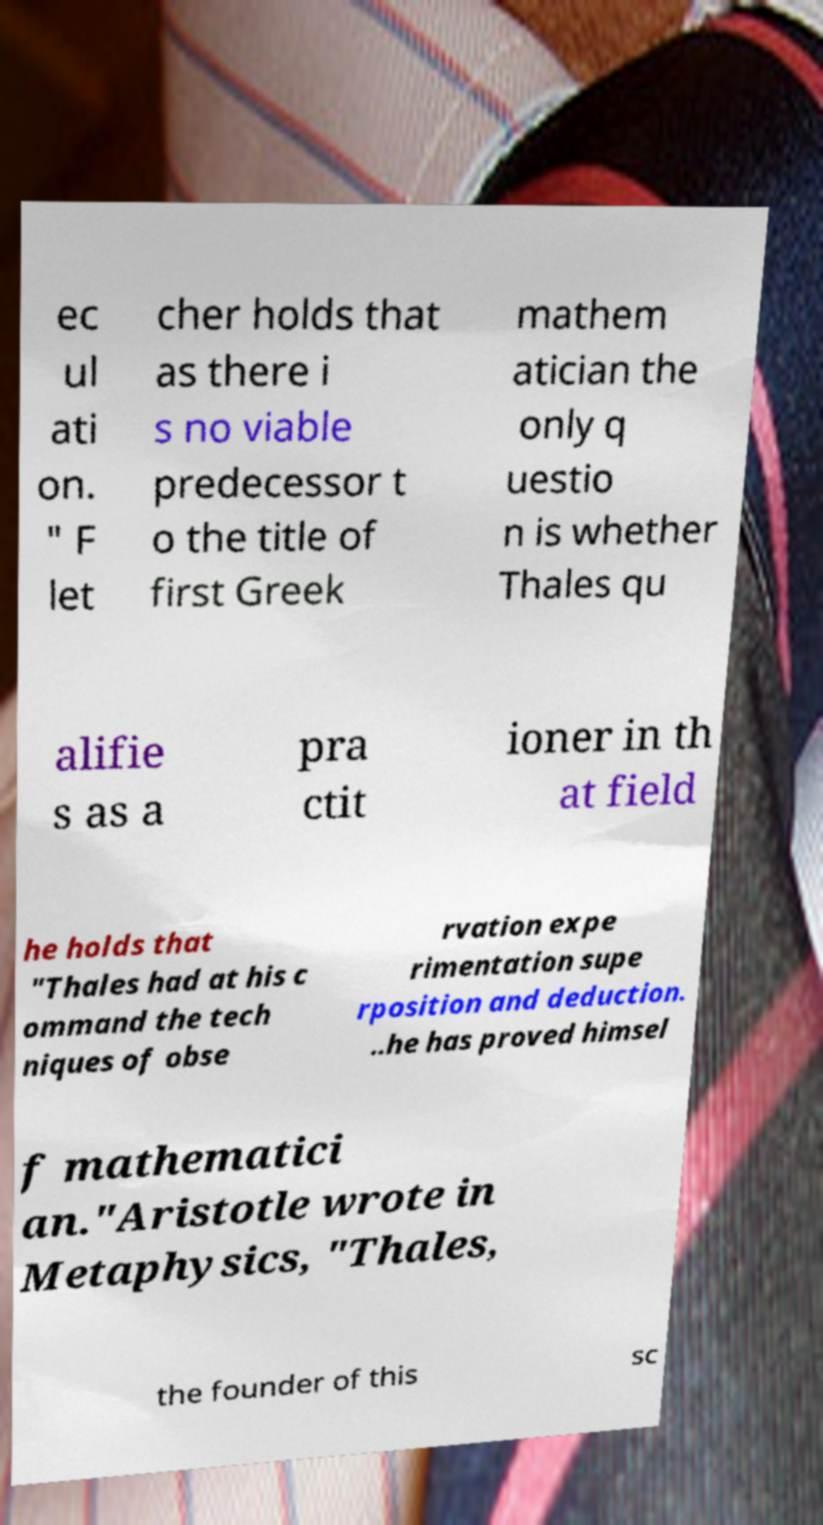What messages or text are displayed in this image? I need them in a readable, typed format. ec ul ati on. " F let cher holds that as there i s no viable predecessor t o the title of first Greek mathem atician the only q uestio n is whether Thales qu alifie s as a pra ctit ioner in th at field he holds that "Thales had at his c ommand the tech niques of obse rvation expe rimentation supe rposition and deduction. ..he has proved himsel f mathematici an."Aristotle wrote in Metaphysics, "Thales, the founder of this sc 